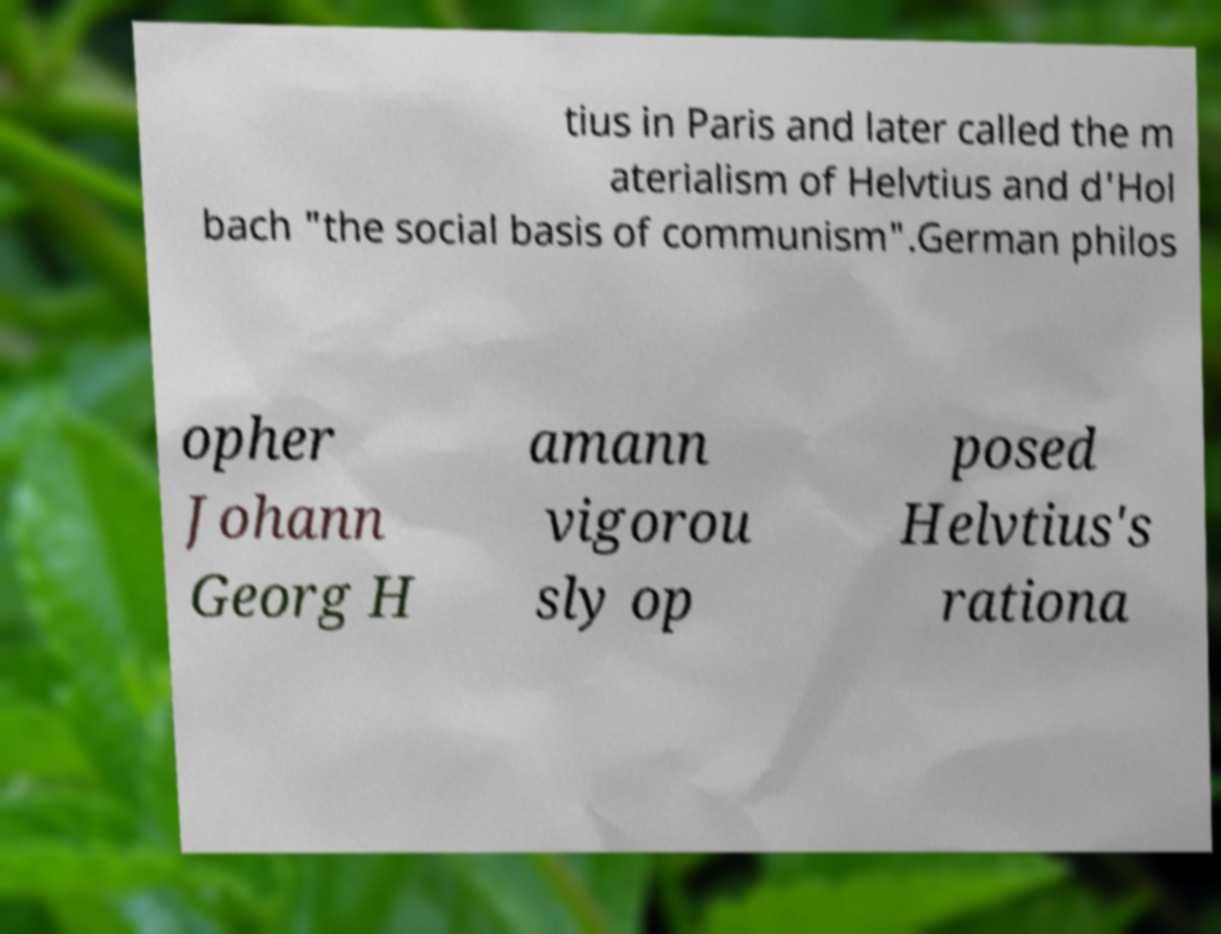Could you extract and type out the text from this image? tius in Paris and later called the m aterialism of Helvtius and d'Hol bach "the social basis of communism".German philos opher Johann Georg H amann vigorou sly op posed Helvtius's rationa 